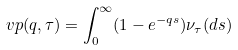Convert formula to latex. <formula><loc_0><loc_0><loc_500><loc_500>\ v p ( q , \tau ) = \int _ { 0 } ^ { \infty } ( 1 - e ^ { - q s } ) \nu _ { \tau } ( d s )</formula> 